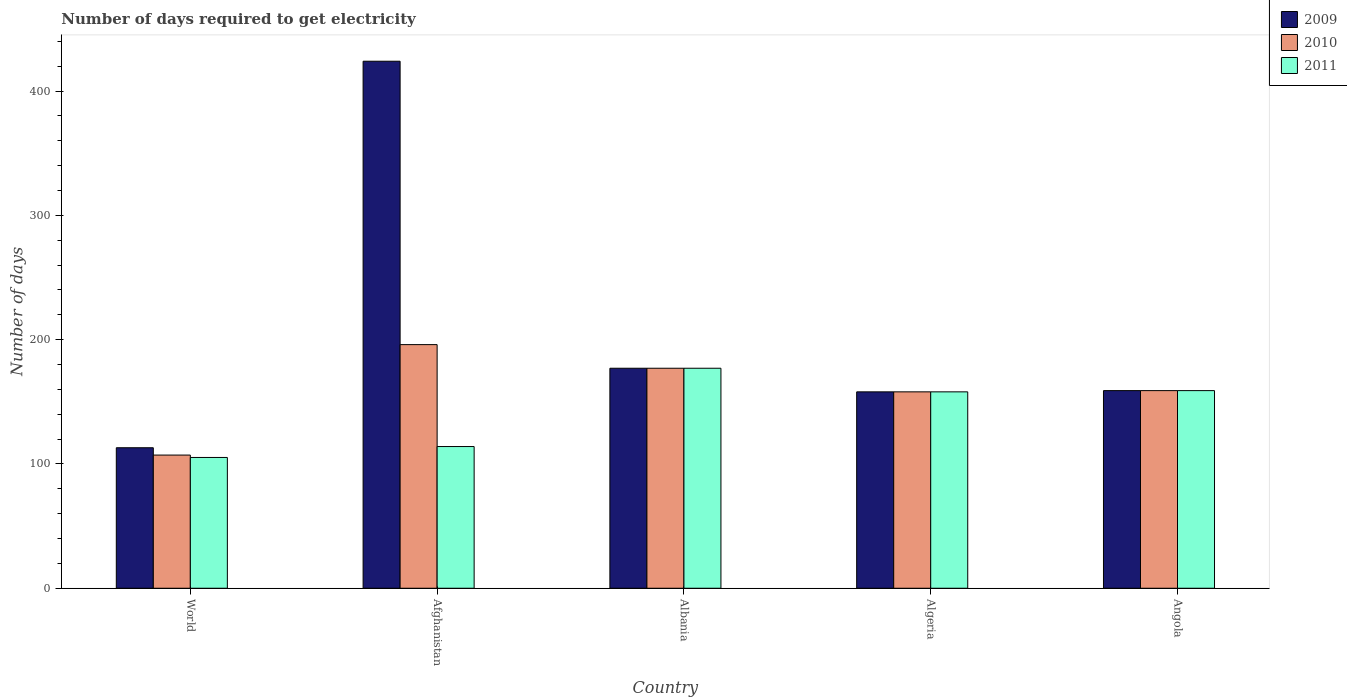Are the number of bars per tick equal to the number of legend labels?
Your answer should be compact. Yes. Are the number of bars on each tick of the X-axis equal?
Provide a succinct answer. Yes. How many bars are there on the 1st tick from the left?
Offer a terse response. 3. How many bars are there on the 4th tick from the right?
Ensure brevity in your answer.  3. What is the label of the 4th group of bars from the left?
Provide a succinct answer. Algeria. In how many cases, is the number of bars for a given country not equal to the number of legend labels?
Give a very brief answer. 0. What is the number of days required to get electricity in in 2010 in Algeria?
Ensure brevity in your answer.  158. Across all countries, what is the maximum number of days required to get electricity in in 2010?
Offer a terse response. 196. Across all countries, what is the minimum number of days required to get electricity in in 2009?
Make the answer very short. 113.03. In which country was the number of days required to get electricity in in 2010 maximum?
Provide a short and direct response. Afghanistan. What is the total number of days required to get electricity in in 2009 in the graph?
Your answer should be compact. 1031.03. What is the average number of days required to get electricity in in 2009 per country?
Provide a succinct answer. 206.21. What is the ratio of the number of days required to get electricity in in 2009 in Albania to that in Angola?
Keep it short and to the point. 1.11. Is the number of days required to get electricity in in 2009 in Afghanistan less than that in World?
Your answer should be very brief. No. Is the difference between the number of days required to get electricity in in 2011 in Afghanistan and Albania greater than the difference between the number of days required to get electricity in in 2010 in Afghanistan and Albania?
Your response must be concise. No. What is the difference between the highest and the second highest number of days required to get electricity in in 2009?
Ensure brevity in your answer.  247. What is the difference between the highest and the lowest number of days required to get electricity in in 2009?
Offer a very short reply. 310.97. Is the sum of the number of days required to get electricity in in 2010 in Afghanistan and Algeria greater than the maximum number of days required to get electricity in in 2011 across all countries?
Ensure brevity in your answer.  Yes. What does the 1st bar from the left in Albania represents?
Your answer should be compact. 2009. How many bars are there?
Provide a short and direct response. 15. How many countries are there in the graph?
Offer a very short reply. 5. Does the graph contain grids?
Your answer should be compact. No. How many legend labels are there?
Ensure brevity in your answer.  3. How are the legend labels stacked?
Offer a terse response. Vertical. What is the title of the graph?
Provide a succinct answer. Number of days required to get electricity. Does "1961" appear as one of the legend labels in the graph?
Your answer should be very brief. No. What is the label or title of the Y-axis?
Offer a very short reply. Number of days. What is the Number of days in 2009 in World?
Give a very brief answer. 113.03. What is the Number of days in 2010 in World?
Your answer should be compact. 107.15. What is the Number of days of 2011 in World?
Ensure brevity in your answer.  105.22. What is the Number of days in 2009 in Afghanistan?
Ensure brevity in your answer.  424. What is the Number of days of 2010 in Afghanistan?
Your answer should be compact. 196. What is the Number of days of 2011 in Afghanistan?
Offer a very short reply. 114. What is the Number of days of 2009 in Albania?
Provide a succinct answer. 177. What is the Number of days of 2010 in Albania?
Your response must be concise. 177. What is the Number of days in 2011 in Albania?
Provide a succinct answer. 177. What is the Number of days in 2009 in Algeria?
Provide a succinct answer. 158. What is the Number of days in 2010 in Algeria?
Offer a very short reply. 158. What is the Number of days in 2011 in Algeria?
Offer a very short reply. 158. What is the Number of days in 2009 in Angola?
Your answer should be very brief. 159. What is the Number of days in 2010 in Angola?
Make the answer very short. 159. What is the Number of days of 2011 in Angola?
Keep it short and to the point. 159. Across all countries, what is the maximum Number of days of 2009?
Offer a very short reply. 424. Across all countries, what is the maximum Number of days of 2010?
Offer a very short reply. 196. Across all countries, what is the maximum Number of days of 2011?
Offer a very short reply. 177. Across all countries, what is the minimum Number of days of 2009?
Ensure brevity in your answer.  113.03. Across all countries, what is the minimum Number of days in 2010?
Your answer should be very brief. 107.15. Across all countries, what is the minimum Number of days in 2011?
Provide a short and direct response. 105.22. What is the total Number of days in 2009 in the graph?
Provide a short and direct response. 1031.03. What is the total Number of days of 2010 in the graph?
Offer a very short reply. 797.15. What is the total Number of days of 2011 in the graph?
Your response must be concise. 713.22. What is the difference between the Number of days of 2009 in World and that in Afghanistan?
Offer a very short reply. -310.97. What is the difference between the Number of days in 2010 in World and that in Afghanistan?
Make the answer very short. -88.85. What is the difference between the Number of days of 2011 in World and that in Afghanistan?
Your response must be concise. -8.78. What is the difference between the Number of days of 2009 in World and that in Albania?
Ensure brevity in your answer.  -63.97. What is the difference between the Number of days in 2010 in World and that in Albania?
Your answer should be very brief. -69.85. What is the difference between the Number of days in 2011 in World and that in Albania?
Your answer should be compact. -71.78. What is the difference between the Number of days of 2009 in World and that in Algeria?
Offer a terse response. -44.97. What is the difference between the Number of days in 2010 in World and that in Algeria?
Keep it short and to the point. -50.85. What is the difference between the Number of days of 2011 in World and that in Algeria?
Offer a very short reply. -52.78. What is the difference between the Number of days in 2009 in World and that in Angola?
Offer a terse response. -45.97. What is the difference between the Number of days in 2010 in World and that in Angola?
Your answer should be very brief. -51.85. What is the difference between the Number of days in 2011 in World and that in Angola?
Ensure brevity in your answer.  -53.78. What is the difference between the Number of days of 2009 in Afghanistan and that in Albania?
Offer a very short reply. 247. What is the difference between the Number of days of 2011 in Afghanistan and that in Albania?
Ensure brevity in your answer.  -63. What is the difference between the Number of days of 2009 in Afghanistan and that in Algeria?
Your answer should be very brief. 266. What is the difference between the Number of days of 2010 in Afghanistan and that in Algeria?
Your answer should be very brief. 38. What is the difference between the Number of days of 2011 in Afghanistan and that in Algeria?
Your answer should be very brief. -44. What is the difference between the Number of days of 2009 in Afghanistan and that in Angola?
Offer a very short reply. 265. What is the difference between the Number of days in 2010 in Afghanistan and that in Angola?
Provide a succinct answer. 37. What is the difference between the Number of days in 2011 in Afghanistan and that in Angola?
Provide a succinct answer. -45. What is the difference between the Number of days of 2009 in Albania and that in Algeria?
Keep it short and to the point. 19. What is the difference between the Number of days of 2009 in Albania and that in Angola?
Provide a short and direct response. 18. What is the difference between the Number of days of 2010 in Albania and that in Angola?
Make the answer very short. 18. What is the difference between the Number of days of 2011 in Albania and that in Angola?
Offer a terse response. 18. What is the difference between the Number of days in 2010 in Algeria and that in Angola?
Your answer should be very brief. -1. What is the difference between the Number of days of 2009 in World and the Number of days of 2010 in Afghanistan?
Your answer should be compact. -82.97. What is the difference between the Number of days of 2009 in World and the Number of days of 2011 in Afghanistan?
Keep it short and to the point. -0.97. What is the difference between the Number of days of 2010 in World and the Number of days of 2011 in Afghanistan?
Your response must be concise. -6.85. What is the difference between the Number of days in 2009 in World and the Number of days in 2010 in Albania?
Keep it short and to the point. -63.97. What is the difference between the Number of days of 2009 in World and the Number of days of 2011 in Albania?
Your answer should be compact. -63.97. What is the difference between the Number of days in 2010 in World and the Number of days in 2011 in Albania?
Provide a succinct answer. -69.85. What is the difference between the Number of days in 2009 in World and the Number of days in 2010 in Algeria?
Provide a succinct answer. -44.97. What is the difference between the Number of days of 2009 in World and the Number of days of 2011 in Algeria?
Make the answer very short. -44.97. What is the difference between the Number of days of 2010 in World and the Number of days of 2011 in Algeria?
Offer a terse response. -50.85. What is the difference between the Number of days of 2009 in World and the Number of days of 2010 in Angola?
Offer a very short reply. -45.97. What is the difference between the Number of days in 2009 in World and the Number of days in 2011 in Angola?
Keep it short and to the point. -45.97. What is the difference between the Number of days in 2010 in World and the Number of days in 2011 in Angola?
Offer a terse response. -51.85. What is the difference between the Number of days in 2009 in Afghanistan and the Number of days in 2010 in Albania?
Give a very brief answer. 247. What is the difference between the Number of days in 2009 in Afghanistan and the Number of days in 2011 in Albania?
Offer a very short reply. 247. What is the difference between the Number of days of 2010 in Afghanistan and the Number of days of 2011 in Albania?
Your answer should be compact. 19. What is the difference between the Number of days of 2009 in Afghanistan and the Number of days of 2010 in Algeria?
Ensure brevity in your answer.  266. What is the difference between the Number of days in 2009 in Afghanistan and the Number of days in 2011 in Algeria?
Give a very brief answer. 266. What is the difference between the Number of days in 2009 in Afghanistan and the Number of days in 2010 in Angola?
Give a very brief answer. 265. What is the difference between the Number of days of 2009 in Afghanistan and the Number of days of 2011 in Angola?
Your answer should be very brief. 265. What is the difference between the Number of days in 2010 in Afghanistan and the Number of days in 2011 in Angola?
Keep it short and to the point. 37. What is the difference between the Number of days of 2009 in Albania and the Number of days of 2011 in Algeria?
Provide a succinct answer. 19. What is the difference between the Number of days in 2009 in Albania and the Number of days in 2010 in Angola?
Your answer should be compact. 18. What is the difference between the Number of days in 2010 in Albania and the Number of days in 2011 in Angola?
Your answer should be very brief. 18. What is the difference between the Number of days of 2009 in Algeria and the Number of days of 2011 in Angola?
Keep it short and to the point. -1. What is the difference between the Number of days of 2010 in Algeria and the Number of days of 2011 in Angola?
Give a very brief answer. -1. What is the average Number of days of 2009 per country?
Your response must be concise. 206.21. What is the average Number of days of 2010 per country?
Ensure brevity in your answer.  159.43. What is the average Number of days of 2011 per country?
Give a very brief answer. 142.64. What is the difference between the Number of days of 2009 and Number of days of 2010 in World?
Offer a very short reply. 5.89. What is the difference between the Number of days in 2009 and Number of days in 2011 in World?
Your response must be concise. 7.81. What is the difference between the Number of days in 2010 and Number of days in 2011 in World?
Give a very brief answer. 1.92. What is the difference between the Number of days of 2009 and Number of days of 2010 in Afghanistan?
Keep it short and to the point. 228. What is the difference between the Number of days in 2009 and Number of days in 2011 in Afghanistan?
Make the answer very short. 310. What is the difference between the Number of days of 2010 and Number of days of 2011 in Afghanistan?
Your answer should be compact. 82. What is the difference between the Number of days in 2010 and Number of days in 2011 in Albania?
Offer a terse response. 0. What is the difference between the Number of days of 2009 and Number of days of 2011 in Algeria?
Offer a terse response. 0. What is the difference between the Number of days in 2010 and Number of days in 2011 in Algeria?
Provide a succinct answer. 0. What is the difference between the Number of days of 2009 and Number of days of 2010 in Angola?
Your answer should be compact. 0. What is the ratio of the Number of days in 2009 in World to that in Afghanistan?
Provide a short and direct response. 0.27. What is the ratio of the Number of days in 2010 in World to that in Afghanistan?
Make the answer very short. 0.55. What is the ratio of the Number of days of 2011 in World to that in Afghanistan?
Give a very brief answer. 0.92. What is the ratio of the Number of days of 2009 in World to that in Albania?
Offer a very short reply. 0.64. What is the ratio of the Number of days of 2010 in World to that in Albania?
Provide a succinct answer. 0.61. What is the ratio of the Number of days in 2011 in World to that in Albania?
Provide a succinct answer. 0.59. What is the ratio of the Number of days of 2009 in World to that in Algeria?
Your answer should be compact. 0.72. What is the ratio of the Number of days of 2010 in World to that in Algeria?
Give a very brief answer. 0.68. What is the ratio of the Number of days in 2011 in World to that in Algeria?
Provide a short and direct response. 0.67. What is the ratio of the Number of days of 2009 in World to that in Angola?
Offer a very short reply. 0.71. What is the ratio of the Number of days of 2010 in World to that in Angola?
Provide a succinct answer. 0.67. What is the ratio of the Number of days of 2011 in World to that in Angola?
Ensure brevity in your answer.  0.66. What is the ratio of the Number of days of 2009 in Afghanistan to that in Albania?
Make the answer very short. 2.4. What is the ratio of the Number of days of 2010 in Afghanistan to that in Albania?
Your answer should be very brief. 1.11. What is the ratio of the Number of days of 2011 in Afghanistan to that in Albania?
Offer a terse response. 0.64. What is the ratio of the Number of days in 2009 in Afghanistan to that in Algeria?
Give a very brief answer. 2.68. What is the ratio of the Number of days of 2010 in Afghanistan to that in Algeria?
Provide a short and direct response. 1.24. What is the ratio of the Number of days of 2011 in Afghanistan to that in Algeria?
Your answer should be very brief. 0.72. What is the ratio of the Number of days of 2009 in Afghanistan to that in Angola?
Your answer should be very brief. 2.67. What is the ratio of the Number of days in 2010 in Afghanistan to that in Angola?
Your answer should be very brief. 1.23. What is the ratio of the Number of days of 2011 in Afghanistan to that in Angola?
Offer a terse response. 0.72. What is the ratio of the Number of days of 2009 in Albania to that in Algeria?
Make the answer very short. 1.12. What is the ratio of the Number of days of 2010 in Albania to that in Algeria?
Your answer should be compact. 1.12. What is the ratio of the Number of days in 2011 in Albania to that in Algeria?
Your response must be concise. 1.12. What is the ratio of the Number of days in 2009 in Albania to that in Angola?
Provide a short and direct response. 1.11. What is the ratio of the Number of days in 2010 in Albania to that in Angola?
Offer a terse response. 1.11. What is the ratio of the Number of days in 2011 in Albania to that in Angola?
Keep it short and to the point. 1.11. What is the ratio of the Number of days in 2009 in Algeria to that in Angola?
Make the answer very short. 0.99. What is the ratio of the Number of days of 2010 in Algeria to that in Angola?
Your answer should be very brief. 0.99. What is the difference between the highest and the second highest Number of days of 2009?
Your answer should be compact. 247. What is the difference between the highest and the second highest Number of days in 2010?
Offer a very short reply. 19. What is the difference between the highest and the second highest Number of days in 2011?
Give a very brief answer. 18. What is the difference between the highest and the lowest Number of days in 2009?
Provide a short and direct response. 310.97. What is the difference between the highest and the lowest Number of days in 2010?
Provide a succinct answer. 88.85. What is the difference between the highest and the lowest Number of days of 2011?
Provide a short and direct response. 71.78. 